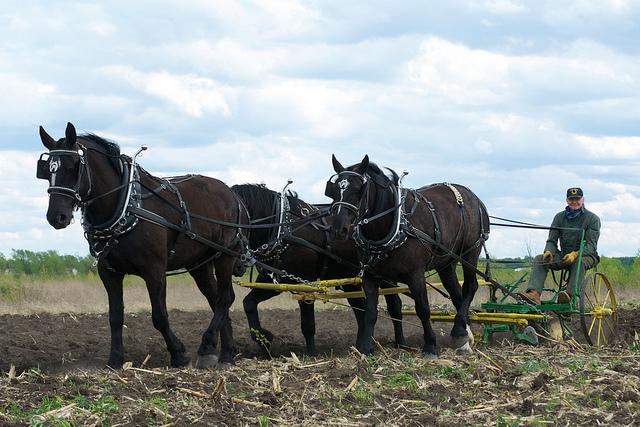How many horses are pictured?
Keep it brief. 3. What color are the wheels?'?
Concise answer only. Yellow. What are the horses pulling that a man is sitting on?
Write a very short answer. Plow. 